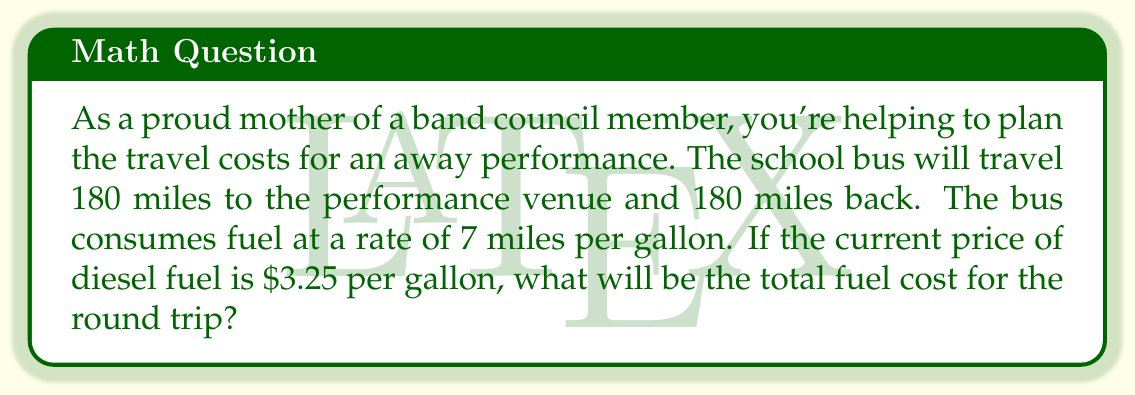Show me your answer to this math problem. Let's break this problem down step by step:

1. Calculate the total distance:
   $$ \text{Total distance} = 180 \text{ miles} + 180 \text{ miles} = 360 \text{ miles} $$

2. Calculate the amount of fuel needed:
   $$ \text{Fuel needed} = \frac{\text{Total distance}}{\text{Fuel efficiency}} = \frac{360 \text{ miles}}{7 \text{ miles/gallon}} = 51.4286 \text{ gallons} $$

3. Calculate the total fuel cost:
   $$ \text{Total fuel cost} = \text{Fuel needed} \times \text{Price per gallon} $$
   $$ = 51.4286 \text{ gallons} \times \$3.25/\text{gallon} = \$167.14 $$

4. Round to the nearest cent:
   $$ \text{Final cost} = \$167.14 $$
Answer: The total fuel cost for the round trip will be $167.14. 